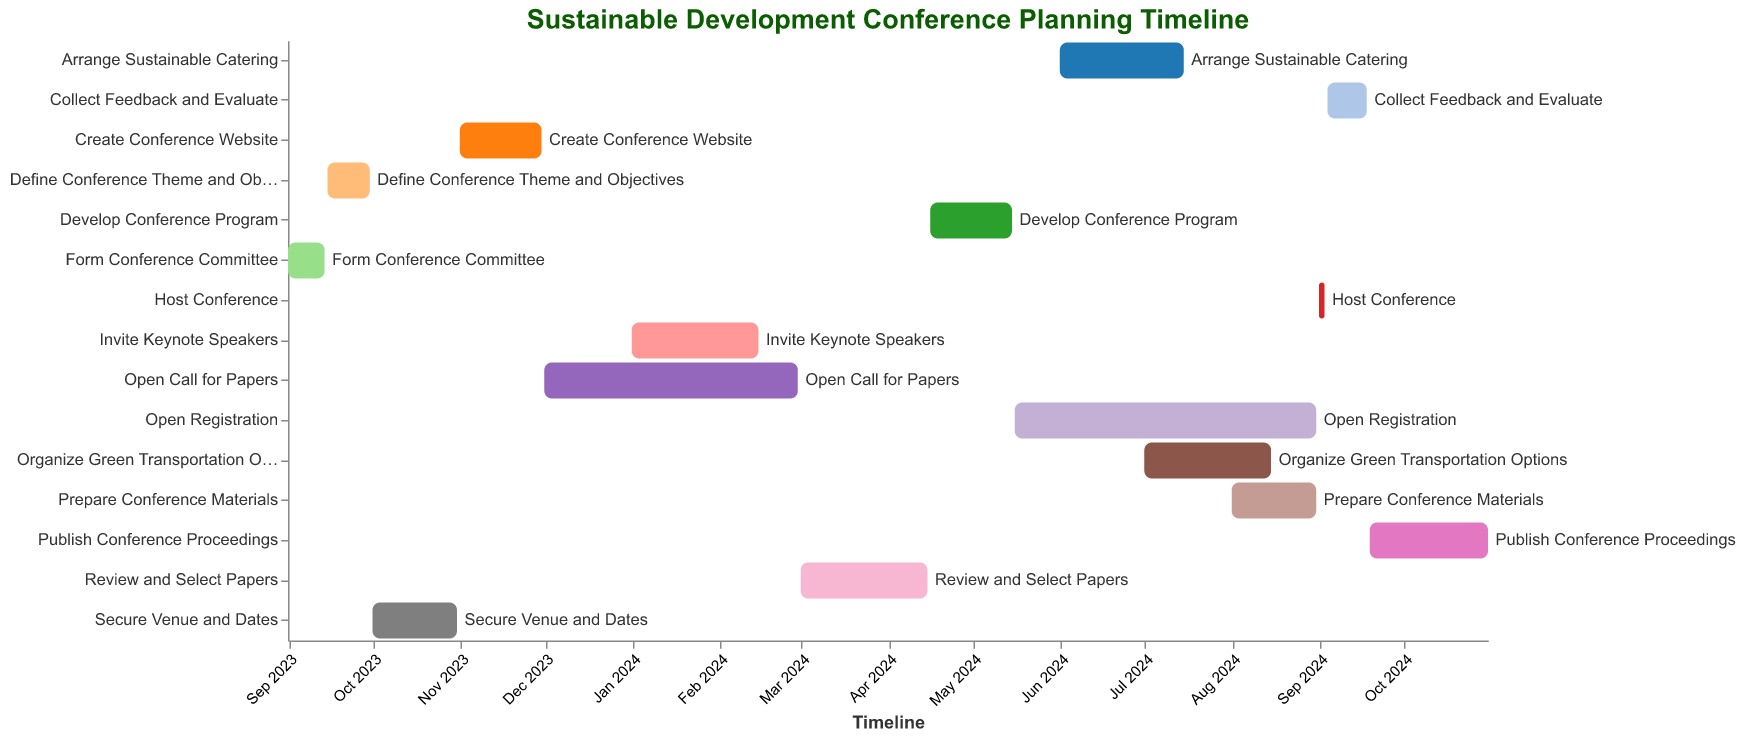What is the title of the Gantt Chart? The title of the Gantt Chart is written at the top and is usually in a larger font size and in a prominent color.
Answer: Sustainable Development Conference Planning Timeline When does the task "Form Conference Committee" start and end? "Form Conference Committee" is the first task on the chart. The start and end dates are adjacent to the task name.
Answer: Start: 2023-09-01, End: 2023-09-14 Which task has the longest duration? To determine the longest duration, look for the bar that spans the most days along the timeline axis. Count the days each bar covers if necessary.
Answer: Open Registration How many days are allocated for reviewing and selecting papers? Find the "Review and Select Papers" task and check the duration mentioned next to the task.
Answer: 46 days What is the total duration from the start of "Form Conference Committee" to the end of "Publish Conference Proceedings"? Note the start date of "Form Conference Committee" and the end date of "Publish Conference Proceedings" and calculate the total number of days in between.
Answer: 426 days Which task overlaps with both "Invite Keynote Speakers" and "Review and Select Papers"? Look for tasks that share the timeline span with both "Invite Keynote Speakers" and "Review and Select Papers".
Answer: None How much longer is "Open Registration" compared to "Create Conference Website"? Subtract the duration of "Create Conference Website" from "Open Registration" to find the difference.
Answer: 78 days Are any tasks scheduled to start in July 2024? Look at the timeline axis for July 2024 and see which tasks have their bars starting in that period.
Answer: Organize Green Transportation Options What tasks are still ongoing when "Prepare Conference Materials" begins? Check which tasks' bars overlap with the start date of "Prepare Conference Materials".
Answer: Open Registration, Organize Green Transportation Options Which tasks are completed before 2024 begins? Identify tasks that have their end dates before January 1, 2024.
Answer: Form Conference Committee, Define Conference Theme and Objectives, Secure Venue and Dates, Create Conference Website 